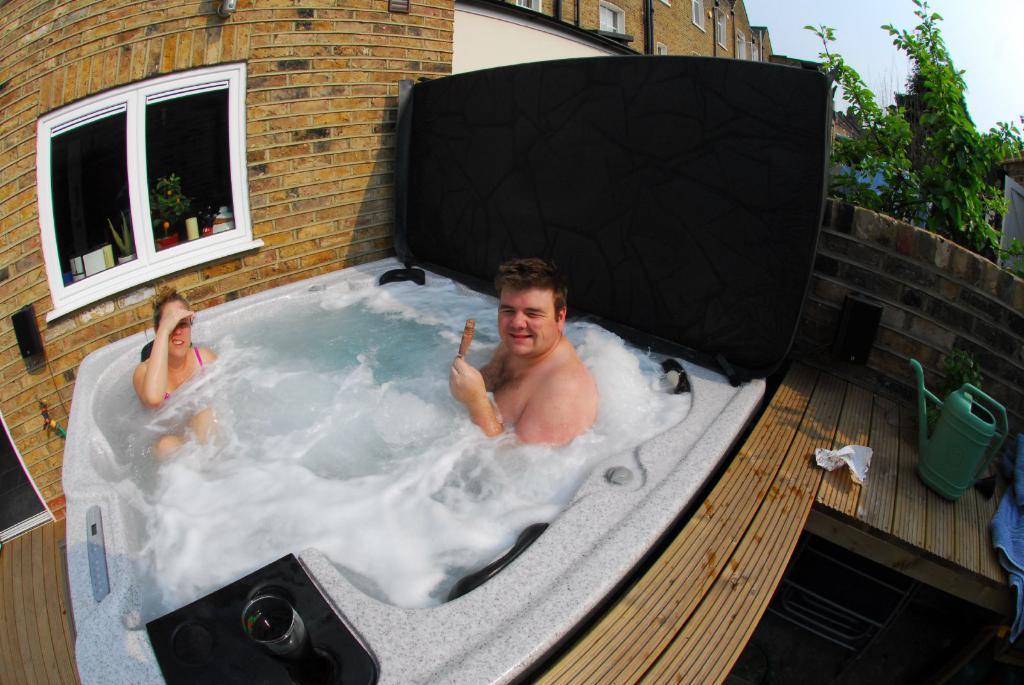In one or two sentences, can you explain what this image depicts? In this image there are persons in the water. In the front there is a glass on the object which is black in colour and there is can which is green colour, there is a towel. In the background there are buildings and on the right side there are trees and there is a window, behind the window there are objects which are green and white in colour and in the front there is an object which is white in colour. 